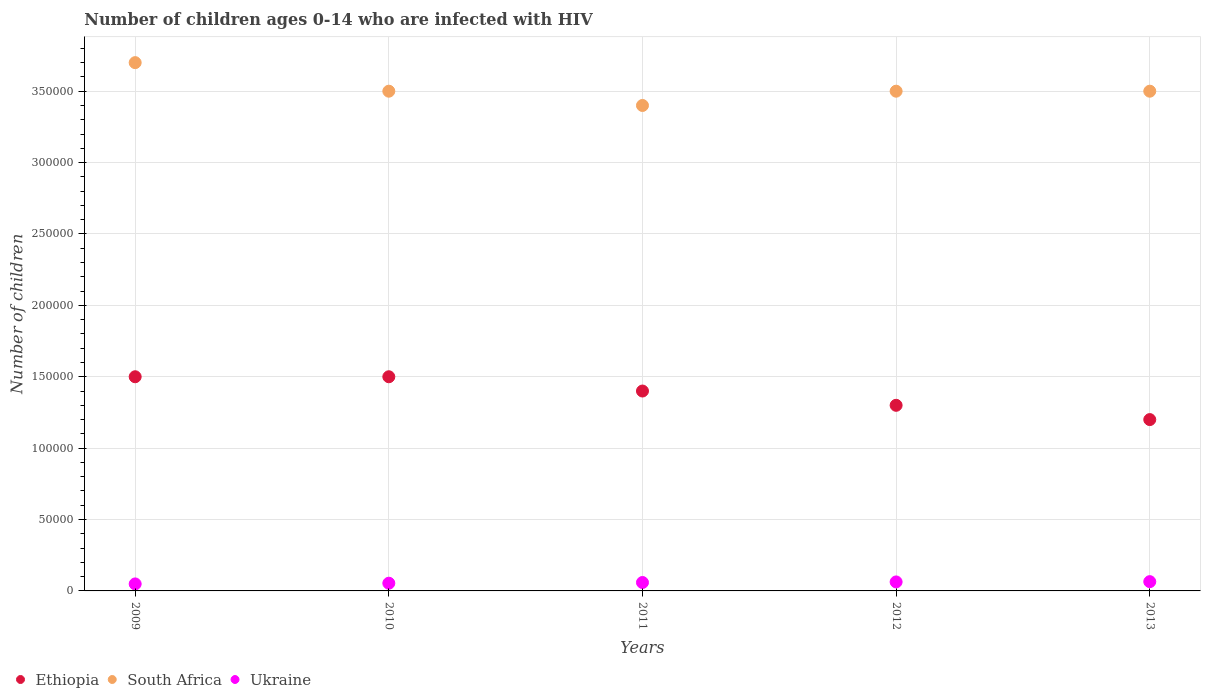How many different coloured dotlines are there?
Give a very brief answer. 3. What is the number of HIV infected children in Ethiopia in 2010?
Offer a very short reply. 1.50e+05. Across all years, what is the maximum number of HIV infected children in Ukraine?
Your answer should be compact. 6500. Across all years, what is the minimum number of HIV infected children in South Africa?
Offer a very short reply. 3.40e+05. In which year was the number of HIV infected children in Ukraine maximum?
Provide a succinct answer. 2013. What is the total number of HIV infected children in South Africa in the graph?
Your answer should be very brief. 1.76e+06. What is the difference between the number of HIV infected children in Ethiopia in 2010 and that in 2012?
Keep it short and to the point. 2.00e+04. What is the difference between the number of HIV infected children in Ukraine in 2010 and the number of HIV infected children in South Africa in 2009?
Make the answer very short. -3.65e+05. What is the average number of HIV infected children in South Africa per year?
Offer a very short reply. 3.52e+05. In the year 2013, what is the difference between the number of HIV infected children in Ethiopia and number of HIV infected children in South Africa?
Your answer should be compact. -2.30e+05. What is the ratio of the number of HIV infected children in Ukraine in 2009 to that in 2011?
Offer a very short reply. 0.83. Is the difference between the number of HIV infected children in Ethiopia in 2012 and 2013 greater than the difference between the number of HIV infected children in South Africa in 2012 and 2013?
Provide a succinct answer. Yes. What is the difference between the highest and the second highest number of HIV infected children in Ethiopia?
Provide a succinct answer. 0. What is the difference between the highest and the lowest number of HIV infected children in Ukraine?
Provide a short and direct response. 1600. In how many years, is the number of HIV infected children in Ethiopia greater than the average number of HIV infected children in Ethiopia taken over all years?
Your answer should be compact. 3. Is it the case that in every year, the sum of the number of HIV infected children in Ethiopia and number of HIV infected children in South Africa  is greater than the number of HIV infected children in Ukraine?
Make the answer very short. Yes. Does the number of HIV infected children in South Africa monotonically increase over the years?
Give a very brief answer. No. How many years are there in the graph?
Your answer should be compact. 5. What is the difference between two consecutive major ticks on the Y-axis?
Your answer should be very brief. 5.00e+04. Are the values on the major ticks of Y-axis written in scientific E-notation?
Make the answer very short. No. Does the graph contain grids?
Offer a very short reply. Yes. Where does the legend appear in the graph?
Your answer should be compact. Bottom left. How are the legend labels stacked?
Ensure brevity in your answer.  Horizontal. What is the title of the graph?
Provide a succinct answer. Number of children ages 0-14 who are infected with HIV. Does "Portugal" appear as one of the legend labels in the graph?
Your answer should be very brief. No. What is the label or title of the Y-axis?
Give a very brief answer. Number of children. What is the Number of children of South Africa in 2009?
Keep it short and to the point. 3.70e+05. What is the Number of children in Ukraine in 2009?
Your response must be concise. 4900. What is the Number of children in South Africa in 2010?
Offer a terse response. 3.50e+05. What is the Number of children of Ukraine in 2010?
Your answer should be compact. 5400. What is the Number of children of Ethiopia in 2011?
Give a very brief answer. 1.40e+05. What is the Number of children of South Africa in 2011?
Make the answer very short. 3.40e+05. What is the Number of children in Ukraine in 2011?
Offer a terse response. 5900. What is the Number of children of Ethiopia in 2012?
Make the answer very short. 1.30e+05. What is the Number of children in South Africa in 2012?
Keep it short and to the point. 3.50e+05. What is the Number of children in Ukraine in 2012?
Provide a succinct answer. 6300. What is the Number of children of Ukraine in 2013?
Offer a terse response. 6500. Across all years, what is the maximum Number of children in Ethiopia?
Provide a succinct answer. 1.50e+05. Across all years, what is the maximum Number of children in Ukraine?
Offer a terse response. 6500. Across all years, what is the minimum Number of children of South Africa?
Offer a very short reply. 3.40e+05. Across all years, what is the minimum Number of children in Ukraine?
Give a very brief answer. 4900. What is the total Number of children in Ethiopia in the graph?
Provide a short and direct response. 6.90e+05. What is the total Number of children of South Africa in the graph?
Offer a very short reply. 1.76e+06. What is the total Number of children in Ukraine in the graph?
Your answer should be very brief. 2.90e+04. What is the difference between the Number of children of Ethiopia in 2009 and that in 2010?
Offer a terse response. 0. What is the difference between the Number of children of South Africa in 2009 and that in 2010?
Ensure brevity in your answer.  2.00e+04. What is the difference between the Number of children in Ukraine in 2009 and that in 2010?
Your response must be concise. -500. What is the difference between the Number of children of Ukraine in 2009 and that in 2011?
Your answer should be compact. -1000. What is the difference between the Number of children of Ethiopia in 2009 and that in 2012?
Provide a short and direct response. 2.00e+04. What is the difference between the Number of children of Ukraine in 2009 and that in 2012?
Your answer should be very brief. -1400. What is the difference between the Number of children in Ethiopia in 2009 and that in 2013?
Provide a short and direct response. 3.00e+04. What is the difference between the Number of children of Ukraine in 2009 and that in 2013?
Your answer should be very brief. -1600. What is the difference between the Number of children in South Africa in 2010 and that in 2011?
Offer a terse response. 10000. What is the difference between the Number of children in Ukraine in 2010 and that in 2011?
Your response must be concise. -500. What is the difference between the Number of children in Ukraine in 2010 and that in 2012?
Offer a terse response. -900. What is the difference between the Number of children of Ethiopia in 2010 and that in 2013?
Your answer should be very brief. 3.00e+04. What is the difference between the Number of children in Ukraine in 2010 and that in 2013?
Your answer should be very brief. -1100. What is the difference between the Number of children of Ukraine in 2011 and that in 2012?
Ensure brevity in your answer.  -400. What is the difference between the Number of children of Ethiopia in 2011 and that in 2013?
Make the answer very short. 2.00e+04. What is the difference between the Number of children in Ukraine in 2011 and that in 2013?
Offer a very short reply. -600. What is the difference between the Number of children of Ethiopia in 2012 and that in 2013?
Ensure brevity in your answer.  10000. What is the difference between the Number of children of South Africa in 2012 and that in 2013?
Provide a succinct answer. 0. What is the difference between the Number of children in Ukraine in 2012 and that in 2013?
Offer a very short reply. -200. What is the difference between the Number of children of Ethiopia in 2009 and the Number of children of South Africa in 2010?
Make the answer very short. -2.00e+05. What is the difference between the Number of children in Ethiopia in 2009 and the Number of children in Ukraine in 2010?
Your answer should be very brief. 1.45e+05. What is the difference between the Number of children in South Africa in 2009 and the Number of children in Ukraine in 2010?
Your answer should be very brief. 3.65e+05. What is the difference between the Number of children in Ethiopia in 2009 and the Number of children in South Africa in 2011?
Your answer should be compact. -1.90e+05. What is the difference between the Number of children of Ethiopia in 2009 and the Number of children of Ukraine in 2011?
Your answer should be compact. 1.44e+05. What is the difference between the Number of children in South Africa in 2009 and the Number of children in Ukraine in 2011?
Offer a very short reply. 3.64e+05. What is the difference between the Number of children in Ethiopia in 2009 and the Number of children in Ukraine in 2012?
Offer a very short reply. 1.44e+05. What is the difference between the Number of children in South Africa in 2009 and the Number of children in Ukraine in 2012?
Give a very brief answer. 3.64e+05. What is the difference between the Number of children in Ethiopia in 2009 and the Number of children in South Africa in 2013?
Keep it short and to the point. -2.00e+05. What is the difference between the Number of children of Ethiopia in 2009 and the Number of children of Ukraine in 2013?
Offer a terse response. 1.44e+05. What is the difference between the Number of children in South Africa in 2009 and the Number of children in Ukraine in 2013?
Provide a short and direct response. 3.64e+05. What is the difference between the Number of children in Ethiopia in 2010 and the Number of children in South Africa in 2011?
Provide a succinct answer. -1.90e+05. What is the difference between the Number of children in Ethiopia in 2010 and the Number of children in Ukraine in 2011?
Keep it short and to the point. 1.44e+05. What is the difference between the Number of children in South Africa in 2010 and the Number of children in Ukraine in 2011?
Keep it short and to the point. 3.44e+05. What is the difference between the Number of children in Ethiopia in 2010 and the Number of children in South Africa in 2012?
Your response must be concise. -2.00e+05. What is the difference between the Number of children of Ethiopia in 2010 and the Number of children of Ukraine in 2012?
Provide a succinct answer. 1.44e+05. What is the difference between the Number of children of South Africa in 2010 and the Number of children of Ukraine in 2012?
Ensure brevity in your answer.  3.44e+05. What is the difference between the Number of children of Ethiopia in 2010 and the Number of children of South Africa in 2013?
Offer a terse response. -2.00e+05. What is the difference between the Number of children in Ethiopia in 2010 and the Number of children in Ukraine in 2013?
Give a very brief answer. 1.44e+05. What is the difference between the Number of children of South Africa in 2010 and the Number of children of Ukraine in 2013?
Your answer should be compact. 3.44e+05. What is the difference between the Number of children in Ethiopia in 2011 and the Number of children in Ukraine in 2012?
Your response must be concise. 1.34e+05. What is the difference between the Number of children in South Africa in 2011 and the Number of children in Ukraine in 2012?
Make the answer very short. 3.34e+05. What is the difference between the Number of children in Ethiopia in 2011 and the Number of children in Ukraine in 2013?
Your answer should be compact. 1.34e+05. What is the difference between the Number of children in South Africa in 2011 and the Number of children in Ukraine in 2013?
Ensure brevity in your answer.  3.34e+05. What is the difference between the Number of children of Ethiopia in 2012 and the Number of children of Ukraine in 2013?
Provide a succinct answer. 1.24e+05. What is the difference between the Number of children of South Africa in 2012 and the Number of children of Ukraine in 2013?
Your answer should be compact. 3.44e+05. What is the average Number of children in Ethiopia per year?
Offer a very short reply. 1.38e+05. What is the average Number of children in South Africa per year?
Your answer should be compact. 3.52e+05. What is the average Number of children in Ukraine per year?
Give a very brief answer. 5800. In the year 2009, what is the difference between the Number of children in Ethiopia and Number of children in Ukraine?
Offer a terse response. 1.45e+05. In the year 2009, what is the difference between the Number of children in South Africa and Number of children in Ukraine?
Give a very brief answer. 3.65e+05. In the year 2010, what is the difference between the Number of children of Ethiopia and Number of children of Ukraine?
Provide a short and direct response. 1.45e+05. In the year 2010, what is the difference between the Number of children in South Africa and Number of children in Ukraine?
Offer a terse response. 3.45e+05. In the year 2011, what is the difference between the Number of children of Ethiopia and Number of children of Ukraine?
Provide a succinct answer. 1.34e+05. In the year 2011, what is the difference between the Number of children of South Africa and Number of children of Ukraine?
Provide a succinct answer. 3.34e+05. In the year 2012, what is the difference between the Number of children in Ethiopia and Number of children in South Africa?
Provide a succinct answer. -2.20e+05. In the year 2012, what is the difference between the Number of children in Ethiopia and Number of children in Ukraine?
Make the answer very short. 1.24e+05. In the year 2012, what is the difference between the Number of children in South Africa and Number of children in Ukraine?
Keep it short and to the point. 3.44e+05. In the year 2013, what is the difference between the Number of children of Ethiopia and Number of children of Ukraine?
Your answer should be very brief. 1.14e+05. In the year 2013, what is the difference between the Number of children of South Africa and Number of children of Ukraine?
Your answer should be compact. 3.44e+05. What is the ratio of the Number of children of Ethiopia in 2009 to that in 2010?
Give a very brief answer. 1. What is the ratio of the Number of children in South Africa in 2009 to that in 2010?
Ensure brevity in your answer.  1.06. What is the ratio of the Number of children in Ukraine in 2009 to that in 2010?
Your response must be concise. 0.91. What is the ratio of the Number of children of Ethiopia in 2009 to that in 2011?
Keep it short and to the point. 1.07. What is the ratio of the Number of children in South Africa in 2009 to that in 2011?
Provide a succinct answer. 1.09. What is the ratio of the Number of children in Ukraine in 2009 to that in 2011?
Offer a very short reply. 0.83. What is the ratio of the Number of children in Ethiopia in 2009 to that in 2012?
Give a very brief answer. 1.15. What is the ratio of the Number of children of South Africa in 2009 to that in 2012?
Your answer should be compact. 1.06. What is the ratio of the Number of children of Ethiopia in 2009 to that in 2013?
Your answer should be compact. 1.25. What is the ratio of the Number of children of South Africa in 2009 to that in 2013?
Provide a succinct answer. 1.06. What is the ratio of the Number of children in Ukraine in 2009 to that in 2013?
Give a very brief answer. 0.75. What is the ratio of the Number of children in Ethiopia in 2010 to that in 2011?
Keep it short and to the point. 1.07. What is the ratio of the Number of children of South Africa in 2010 to that in 2011?
Offer a terse response. 1.03. What is the ratio of the Number of children of Ukraine in 2010 to that in 2011?
Ensure brevity in your answer.  0.92. What is the ratio of the Number of children of Ethiopia in 2010 to that in 2012?
Your answer should be very brief. 1.15. What is the ratio of the Number of children of South Africa in 2010 to that in 2012?
Your answer should be compact. 1. What is the ratio of the Number of children in Ukraine in 2010 to that in 2012?
Make the answer very short. 0.86. What is the ratio of the Number of children of Ethiopia in 2010 to that in 2013?
Your response must be concise. 1.25. What is the ratio of the Number of children in Ukraine in 2010 to that in 2013?
Offer a very short reply. 0.83. What is the ratio of the Number of children in South Africa in 2011 to that in 2012?
Provide a succinct answer. 0.97. What is the ratio of the Number of children of Ukraine in 2011 to that in 2012?
Make the answer very short. 0.94. What is the ratio of the Number of children of Ethiopia in 2011 to that in 2013?
Ensure brevity in your answer.  1.17. What is the ratio of the Number of children of South Africa in 2011 to that in 2013?
Offer a very short reply. 0.97. What is the ratio of the Number of children in Ukraine in 2011 to that in 2013?
Offer a very short reply. 0.91. What is the ratio of the Number of children in Ethiopia in 2012 to that in 2013?
Your answer should be very brief. 1.08. What is the ratio of the Number of children of South Africa in 2012 to that in 2013?
Your answer should be very brief. 1. What is the ratio of the Number of children in Ukraine in 2012 to that in 2013?
Your answer should be compact. 0.97. What is the difference between the highest and the second highest Number of children in Ethiopia?
Provide a short and direct response. 0. What is the difference between the highest and the second highest Number of children in South Africa?
Give a very brief answer. 2.00e+04. What is the difference between the highest and the second highest Number of children of Ukraine?
Your response must be concise. 200. What is the difference between the highest and the lowest Number of children of South Africa?
Give a very brief answer. 3.00e+04. What is the difference between the highest and the lowest Number of children of Ukraine?
Provide a succinct answer. 1600. 